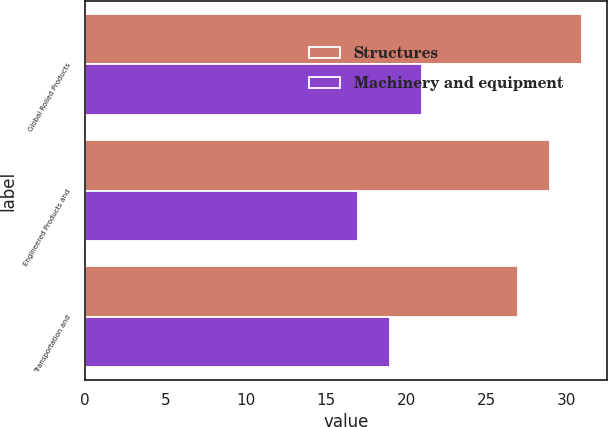Convert chart. <chart><loc_0><loc_0><loc_500><loc_500><stacked_bar_chart><ecel><fcel>Global Rolled Products<fcel>Engineered Products and<fcel>Transportation and<nl><fcel>Structures<fcel>31<fcel>29<fcel>27<nl><fcel>Machinery and equipment<fcel>21<fcel>17<fcel>19<nl></chart> 